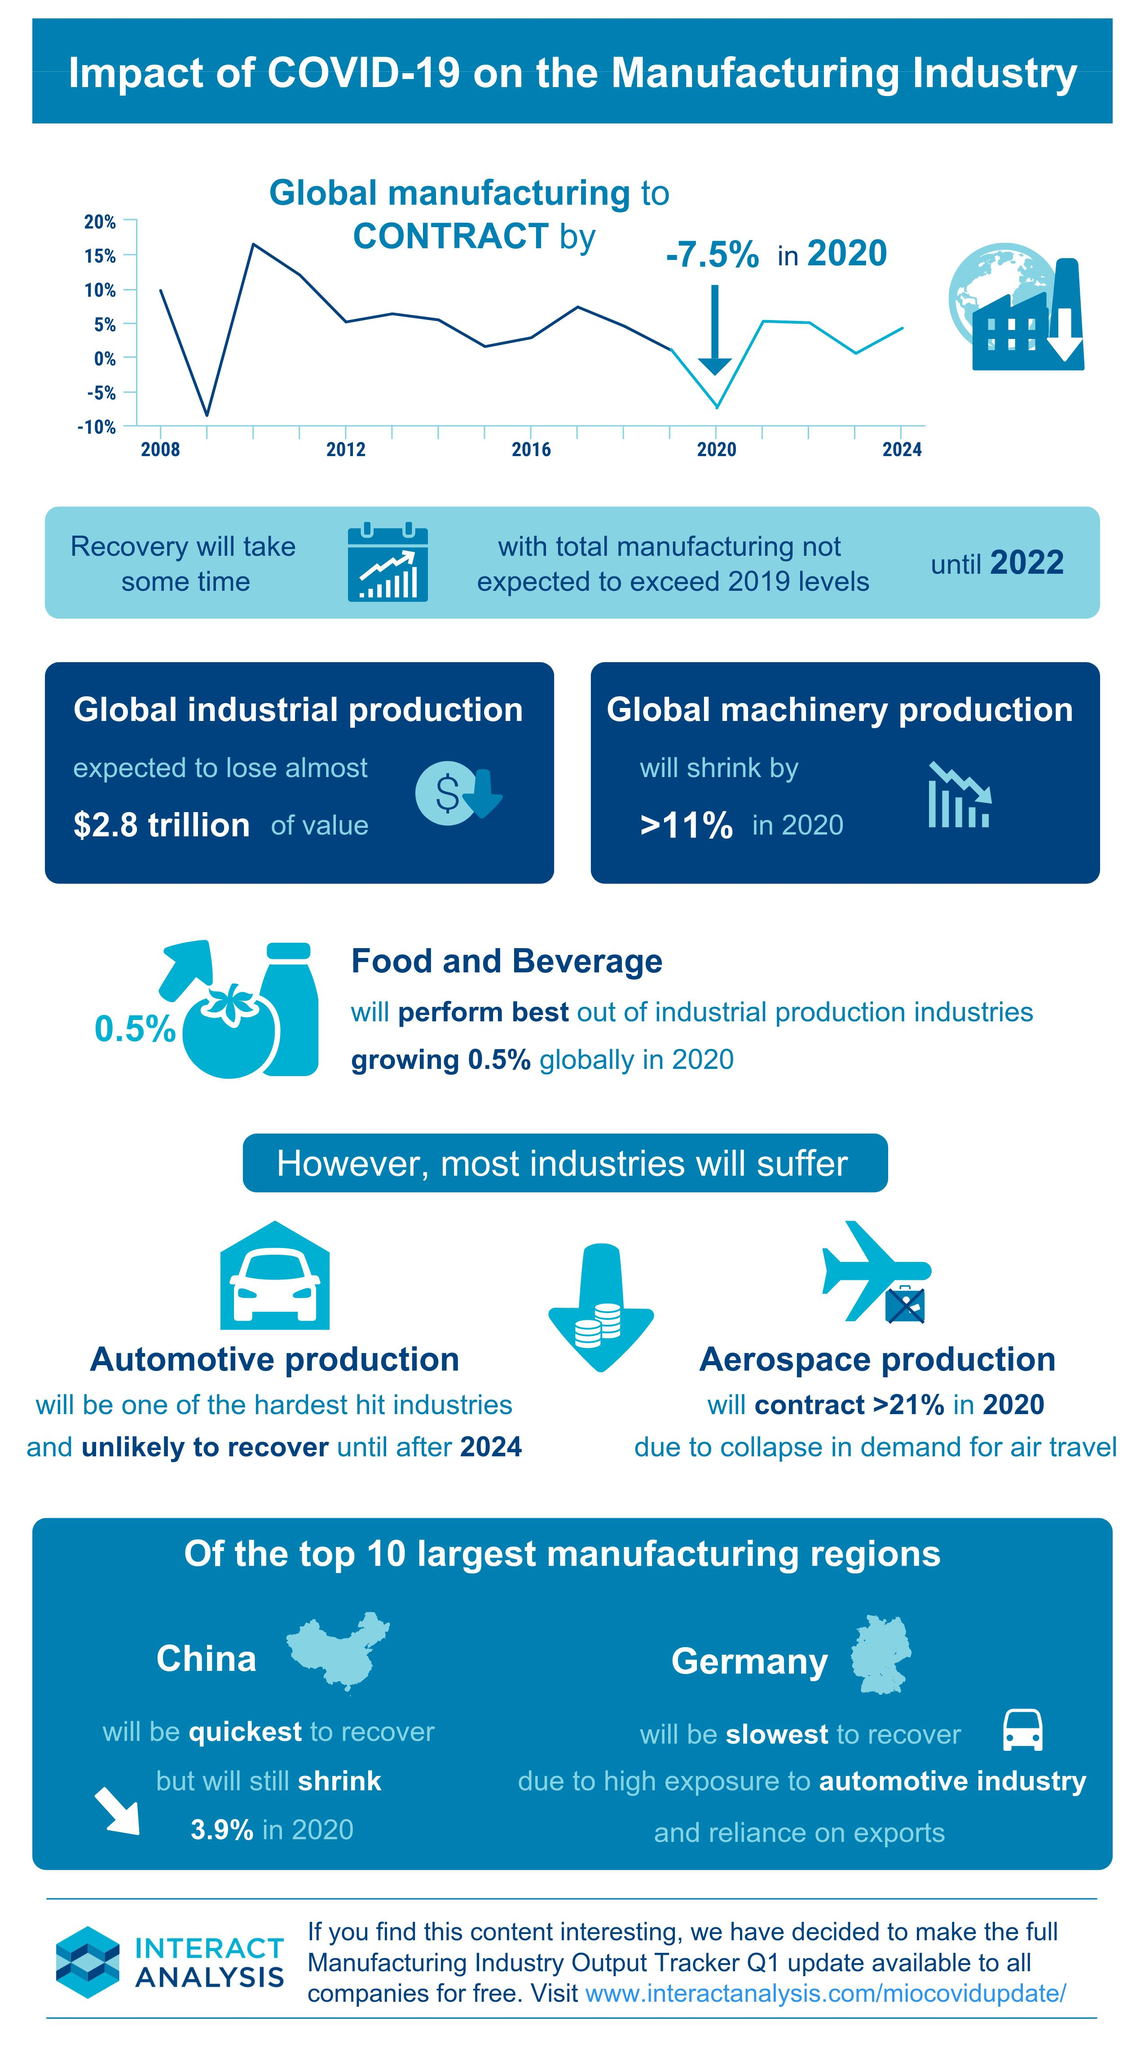Give some essential details in this illustration. It is predicted that the food and beverage industry will perform well globally in 2020. China is expected to recover faster than other manufacturing regions. It is not anticipated that the complete recovery of the manufacturing industry will occur until the year 2022. The aerospace production industry has been significantly impacted by the decline in demand for air travel, resulting in hardship for the sector. Germany is a European country that heavily relies on the automotive industry and is known for its significant exports in this field. 